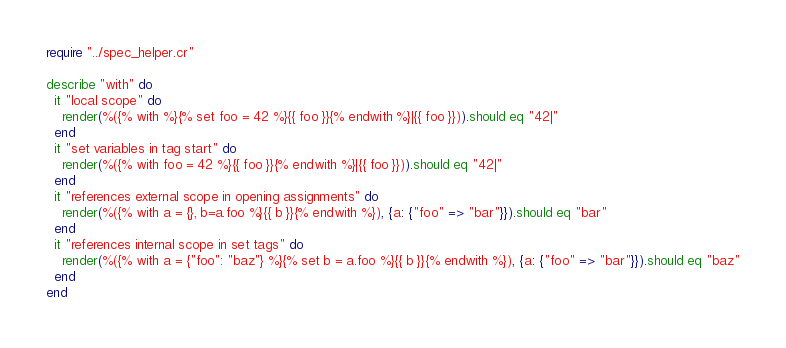Convert code to text. <code><loc_0><loc_0><loc_500><loc_500><_Crystal_>require "../spec_helper.cr"

describe "with" do
  it "local scope" do
    render(%({% with %}{% set foo = 42 %}{{ foo }}{% endwith %}|{{ foo }})).should eq "42|"
  end
  it "set variables in tag start" do
    render(%({% with foo = 42 %}{{ foo }}{% endwith %}|{{ foo }})).should eq "42|"
  end
  it "references external scope in opening assignments" do
    render(%({% with a = {}, b=a.foo %}{{ b }}{% endwith %}), {a: {"foo" => "bar"}}).should eq "bar"
  end
  it "references internal scope in set tags" do
    render(%({% with a = {"foo": "baz"} %}{% set b = a.foo %}{{ b }}{% endwith %}), {a: {"foo" => "bar"}}).should eq "baz"
  end
end
</code> 